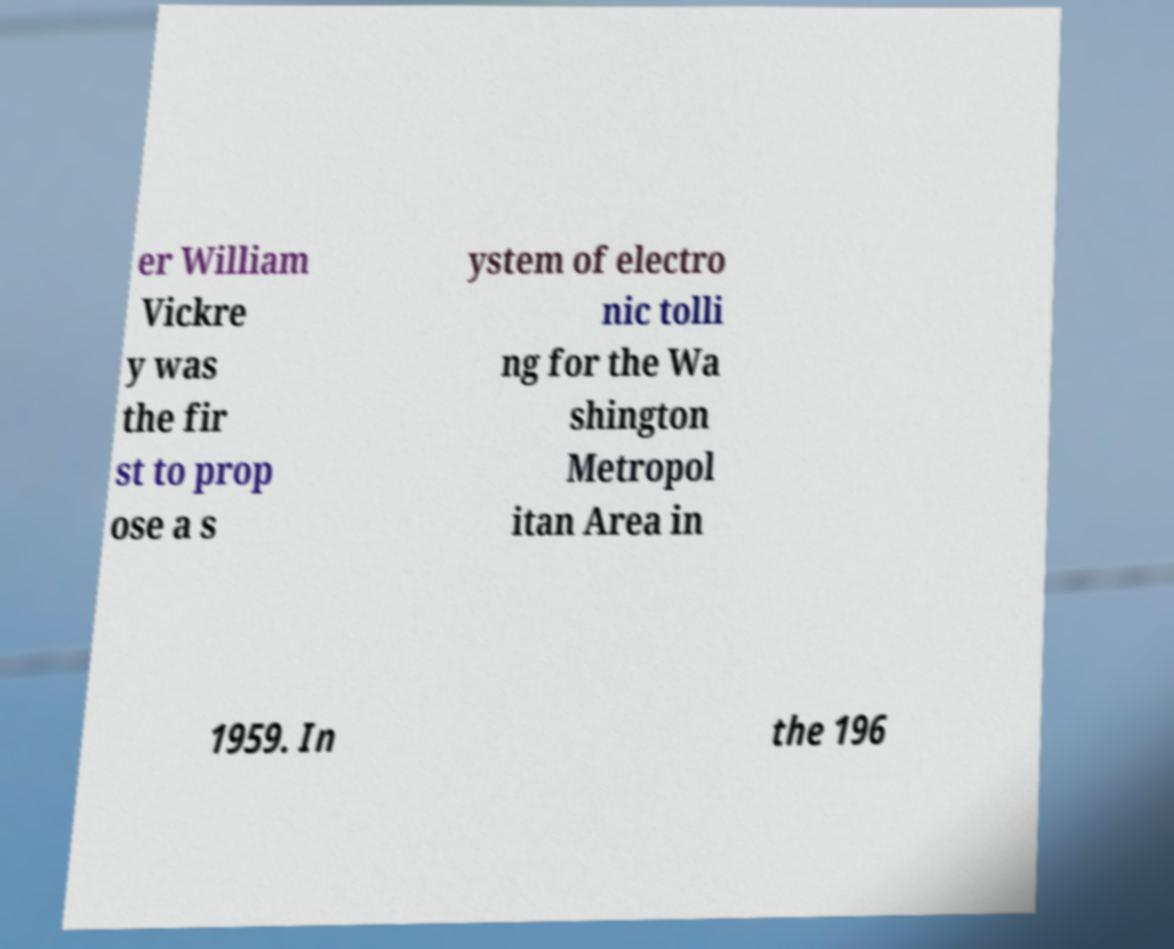Could you extract and type out the text from this image? er William Vickre y was the fir st to prop ose a s ystem of electro nic tolli ng for the Wa shington Metropol itan Area in 1959. In the 196 